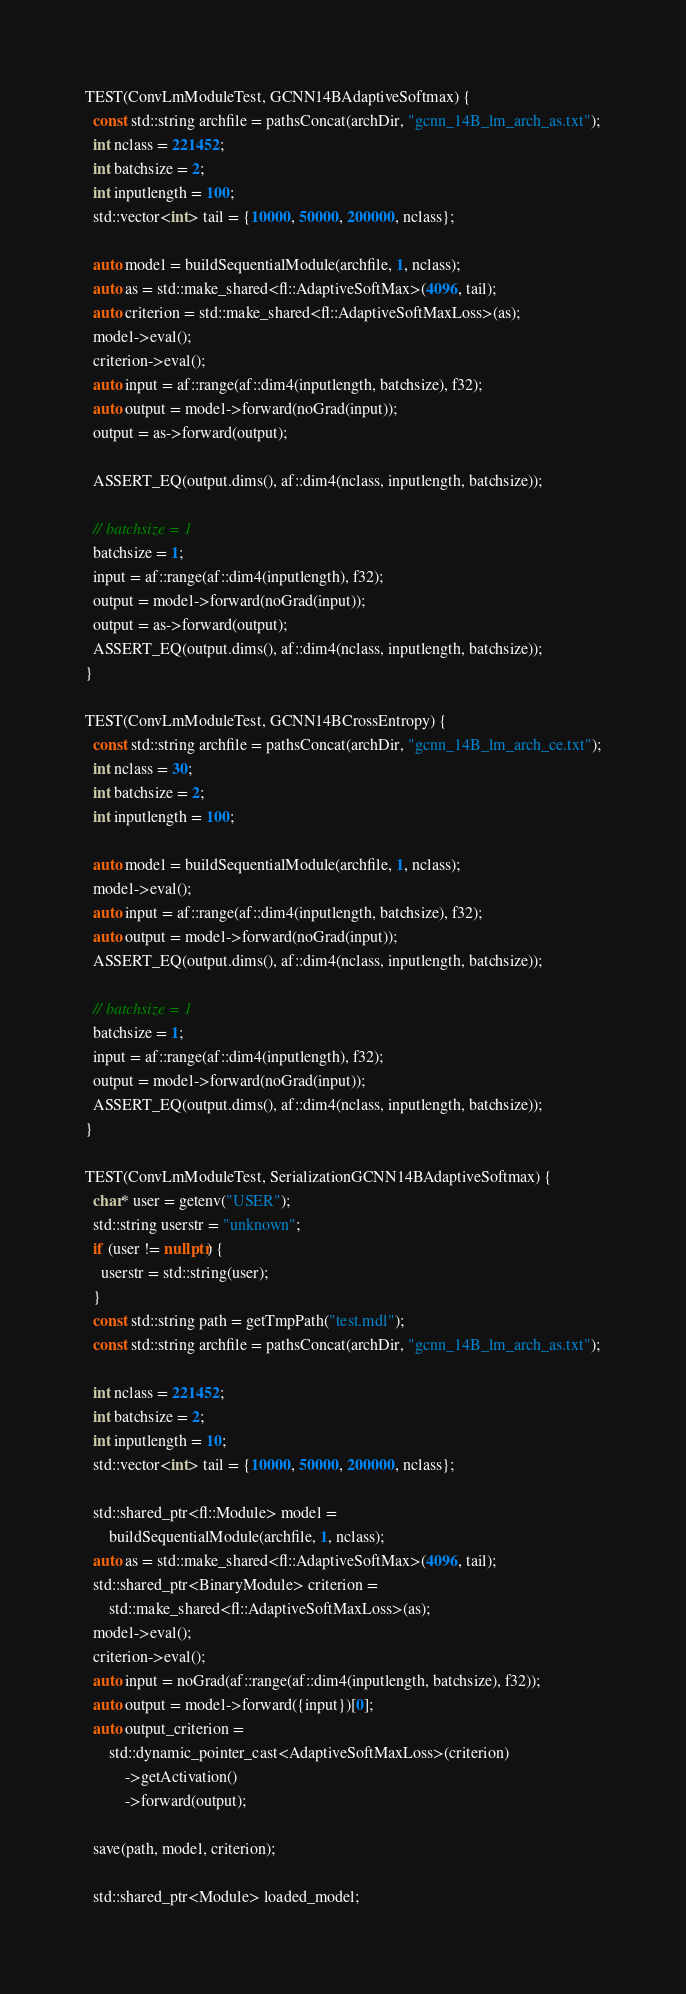<code> <loc_0><loc_0><loc_500><loc_500><_C++_>
TEST(ConvLmModuleTest, GCNN14BAdaptiveSoftmax) {
  const std::string archfile = pathsConcat(archDir, "gcnn_14B_lm_arch_as.txt");
  int nclass = 221452;
  int batchsize = 2;
  int inputlength = 100;
  std::vector<int> tail = {10000, 50000, 200000, nclass};

  auto model = buildSequentialModule(archfile, 1, nclass);
  auto as = std::make_shared<fl::AdaptiveSoftMax>(4096, tail);
  auto criterion = std::make_shared<fl::AdaptiveSoftMaxLoss>(as);
  model->eval();
  criterion->eval();
  auto input = af::range(af::dim4(inputlength, batchsize), f32);
  auto output = model->forward(noGrad(input));
  output = as->forward(output);

  ASSERT_EQ(output.dims(), af::dim4(nclass, inputlength, batchsize));

  // batchsize = 1
  batchsize = 1;
  input = af::range(af::dim4(inputlength), f32);
  output = model->forward(noGrad(input));
  output = as->forward(output);
  ASSERT_EQ(output.dims(), af::dim4(nclass, inputlength, batchsize));
}

TEST(ConvLmModuleTest, GCNN14BCrossEntropy) {
  const std::string archfile = pathsConcat(archDir, "gcnn_14B_lm_arch_ce.txt");
  int nclass = 30;
  int batchsize = 2;
  int inputlength = 100;

  auto model = buildSequentialModule(archfile, 1, nclass);
  model->eval();
  auto input = af::range(af::dim4(inputlength, batchsize), f32);
  auto output = model->forward(noGrad(input));
  ASSERT_EQ(output.dims(), af::dim4(nclass, inputlength, batchsize));

  // batchsize = 1
  batchsize = 1;
  input = af::range(af::dim4(inputlength), f32);
  output = model->forward(noGrad(input));
  ASSERT_EQ(output.dims(), af::dim4(nclass, inputlength, batchsize));
}

TEST(ConvLmModuleTest, SerializationGCNN14BAdaptiveSoftmax) {
  char* user = getenv("USER");
  std::string userstr = "unknown";
  if (user != nullptr) {
    userstr = std::string(user);
  }
  const std::string path = getTmpPath("test.mdl");
  const std::string archfile = pathsConcat(archDir, "gcnn_14B_lm_arch_as.txt");

  int nclass = 221452;
  int batchsize = 2;
  int inputlength = 10;
  std::vector<int> tail = {10000, 50000, 200000, nclass};

  std::shared_ptr<fl::Module> model =
      buildSequentialModule(archfile, 1, nclass);
  auto as = std::make_shared<fl::AdaptiveSoftMax>(4096, tail);
  std::shared_ptr<BinaryModule> criterion =
      std::make_shared<fl::AdaptiveSoftMaxLoss>(as);
  model->eval();
  criterion->eval();
  auto input = noGrad(af::range(af::dim4(inputlength, batchsize), f32));
  auto output = model->forward({input})[0];
  auto output_criterion =
      std::dynamic_pointer_cast<AdaptiveSoftMaxLoss>(criterion)
          ->getActivation()
          ->forward(output);

  save(path, model, criterion);

  std::shared_ptr<Module> loaded_model;</code> 